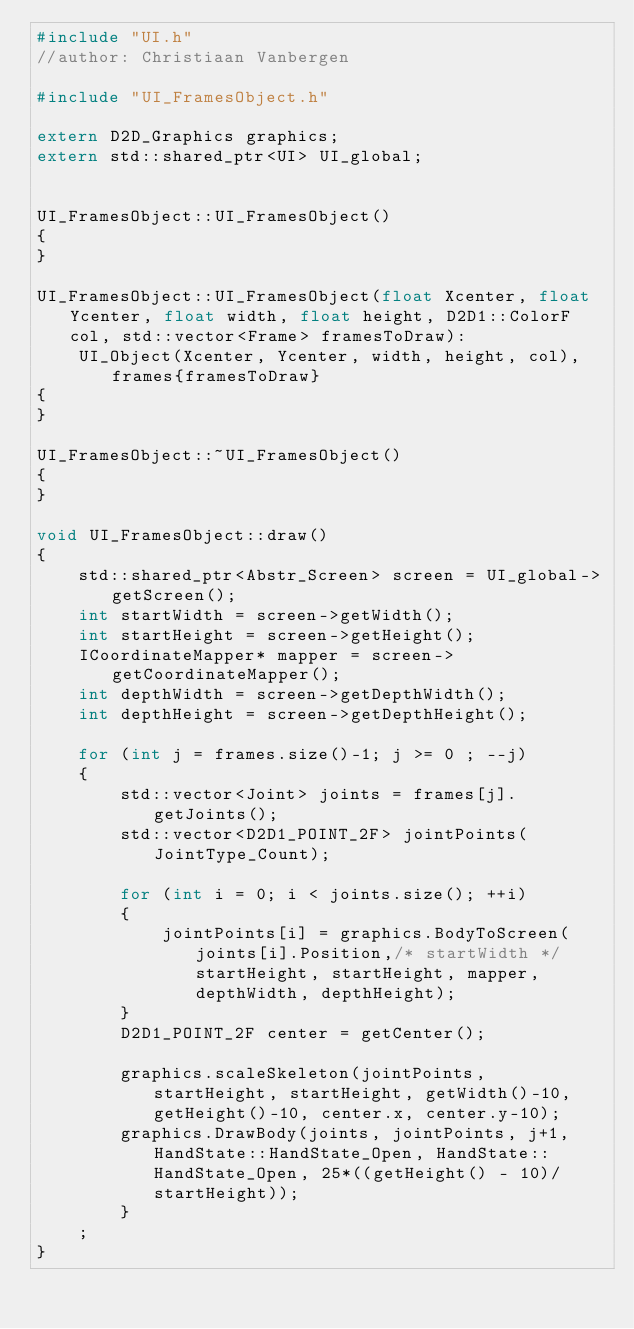Convert code to text. <code><loc_0><loc_0><loc_500><loc_500><_C++_>#include "UI.h"
//author: Christiaan Vanbergen 

#include "UI_FramesObject.h"

extern D2D_Graphics graphics;
extern std::shared_ptr<UI> UI_global;


UI_FramesObject::UI_FramesObject()
{
}

UI_FramesObject::UI_FramesObject(float Xcenter, float Ycenter, float width, float height, D2D1::ColorF col, std::vector<Frame> framesToDraw):
	UI_Object(Xcenter, Ycenter, width, height, col), frames{framesToDraw}
{
}

UI_FramesObject::~UI_FramesObject()
{
}

void UI_FramesObject::draw()
{
	std::shared_ptr<Abstr_Screen> screen = UI_global->getScreen();
	int startWidth = screen->getWidth();
	int startHeight = screen->getHeight();
	ICoordinateMapper* mapper = screen->getCoordinateMapper();
	int depthWidth = screen->getDepthWidth();
	int depthHeight = screen->getDepthHeight();

	for (int j = frames.size()-1; j >= 0 ; --j)
	{
		std::vector<Joint> joints = frames[j].getJoints();
		std::vector<D2D1_POINT_2F> jointPoints(JointType_Count);

		for (int i = 0; i < joints.size(); ++i)
		{
			jointPoints[i] = graphics.BodyToScreen(joints[i].Position,/* startWidth */startHeight, startHeight, mapper, depthWidth, depthHeight);
		}
		D2D1_POINT_2F center = getCenter();

		graphics.scaleSkeleton(jointPoints, startHeight, startHeight, getWidth()-10, getHeight()-10, center.x, center.y-10);
		graphics.DrawBody(joints, jointPoints, j+1,HandState::HandState_Open, HandState::HandState_Open, 25*((getHeight() - 10)/startHeight));
		}
	;
}
</code> 